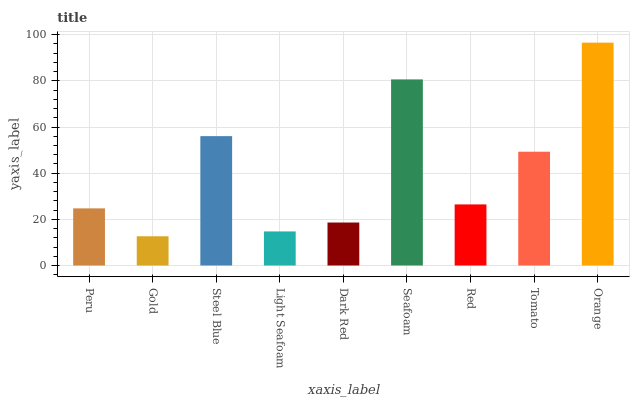Is Gold the minimum?
Answer yes or no. Yes. Is Orange the maximum?
Answer yes or no. Yes. Is Steel Blue the minimum?
Answer yes or no. No. Is Steel Blue the maximum?
Answer yes or no. No. Is Steel Blue greater than Gold?
Answer yes or no. Yes. Is Gold less than Steel Blue?
Answer yes or no. Yes. Is Gold greater than Steel Blue?
Answer yes or no. No. Is Steel Blue less than Gold?
Answer yes or no. No. Is Red the high median?
Answer yes or no. Yes. Is Red the low median?
Answer yes or no. Yes. Is Orange the high median?
Answer yes or no. No. Is Tomato the low median?
Answer yes or no. No. 